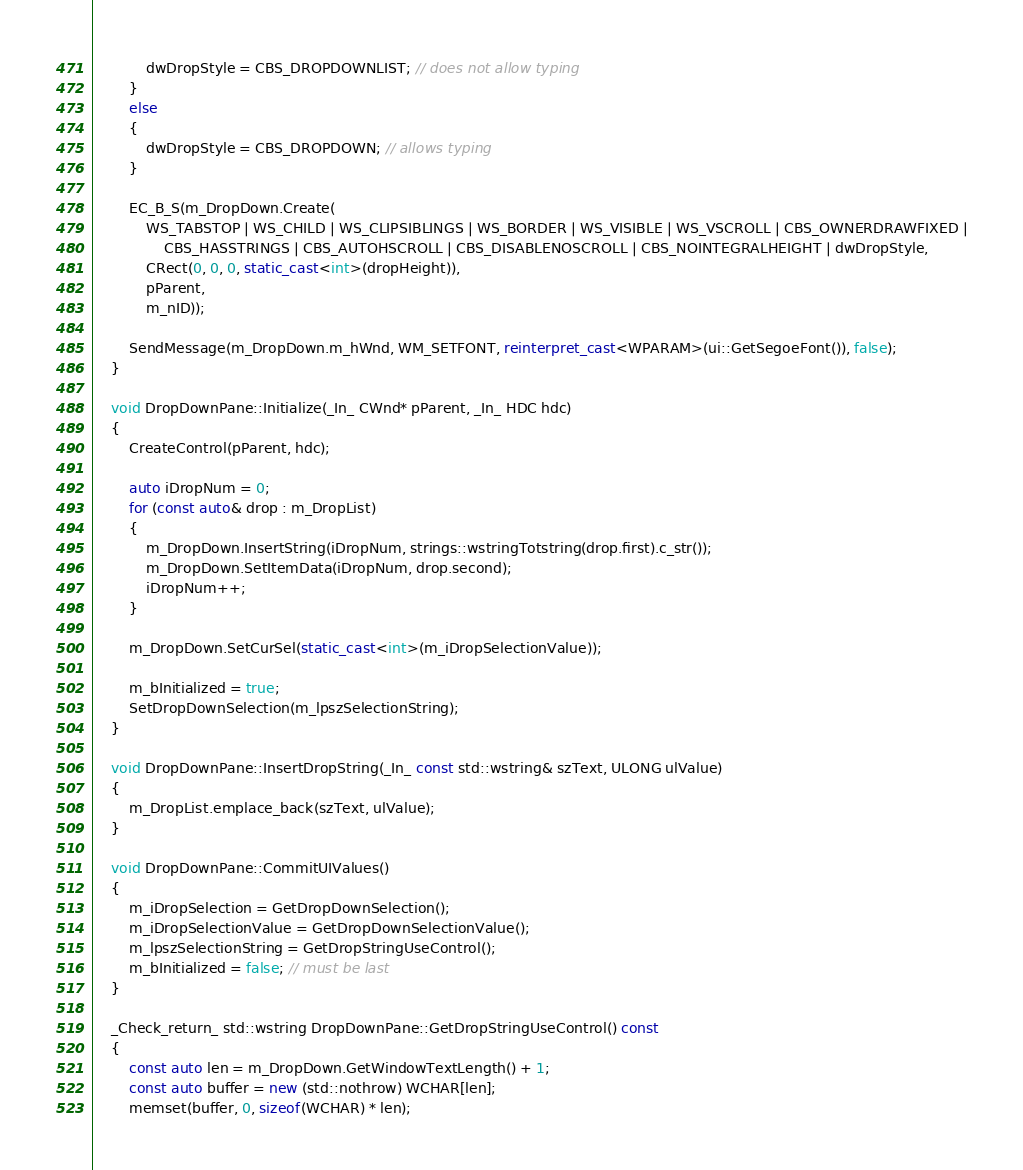Convert code to text. <code><loc_0><loc_0><loc_500><loc_500><_C++_>			dwDropStyle = CBS_DROPDOWNLIST; // does not allow typing
		}
		else
		{
			dwDropStyle = CBS_DROPDOWN; // allows typing
		}

		EC_B_S(m_DropDown.Create(
			WS_TABSTOP | WS_CHILD | WS_CLIPSIBLINGS | WS_BORDER | WS_VISIBLE | WS_VSCROLL | CBS_OWNERDRAWFIXED |
				CBS_HASSTRINGS | CBS_AUTOHSCROLL | CBS_DISABLENOSCROLL | CBS_NOINTEGRALHEIGHT | dwDropStyle,
			CRect(0, 0, 0, static_cast<int>(dropHeight)),
			pParent,
			m_nID));

		SendMessage(m_DropDown.m_hWnd, WM_SETFONT, reinterpret_cast<WPARAM>(ui::GetSegoeFont()), false);
	}

	void DropDownPane::Initialize(_In_ CWnd* pParent, _In_ HDC hdc)
	{
		CreateControl(pParent, hdc);

		auto iDropNum = 0;
		for (const auto& drop : m_DropList)
		{
			m_DropDown.InsertString(iDropNum, strings::wstringTotstring(drop.first).c_str());
			m_DropDown.SetItemData(iDropNum, drop.second);
			iDropNum++;
		}

		m_DropDown.SetCurSel(static_cast<int>(m_iDropSelectionValue));

		m_bInitialized = true;
		SetDropDownSelection(m_lpszSelectionString);
	}

	void DropDownPane::InsertDropString(_In_ const std::wstring& szText, ULONG ulValue)
	{
		m_DropList.emplace_back(szText, ulValue);
	}

	void DropDownPane::CommitUIValues()
	{
		m_iDropSelection = GetDropDownSelection();
		m_iDropSelectionValue = GetDropDownSelectionValue();
		m_lpszSelectionString = GetDropStringUseControl();
		m_bInitialized = false; // must be last
	}

	_Check_return_ std::wstring DropDownPane::GetDropStringUseControl() const
	{
		const auto len = m_DropDown.GetWindowTextLength() + 1;
		const auto buffer = new (std::nothrow) WCHAR[len];
		memset(buffer, 0, sizeof(WCHAR) * len);</code> 